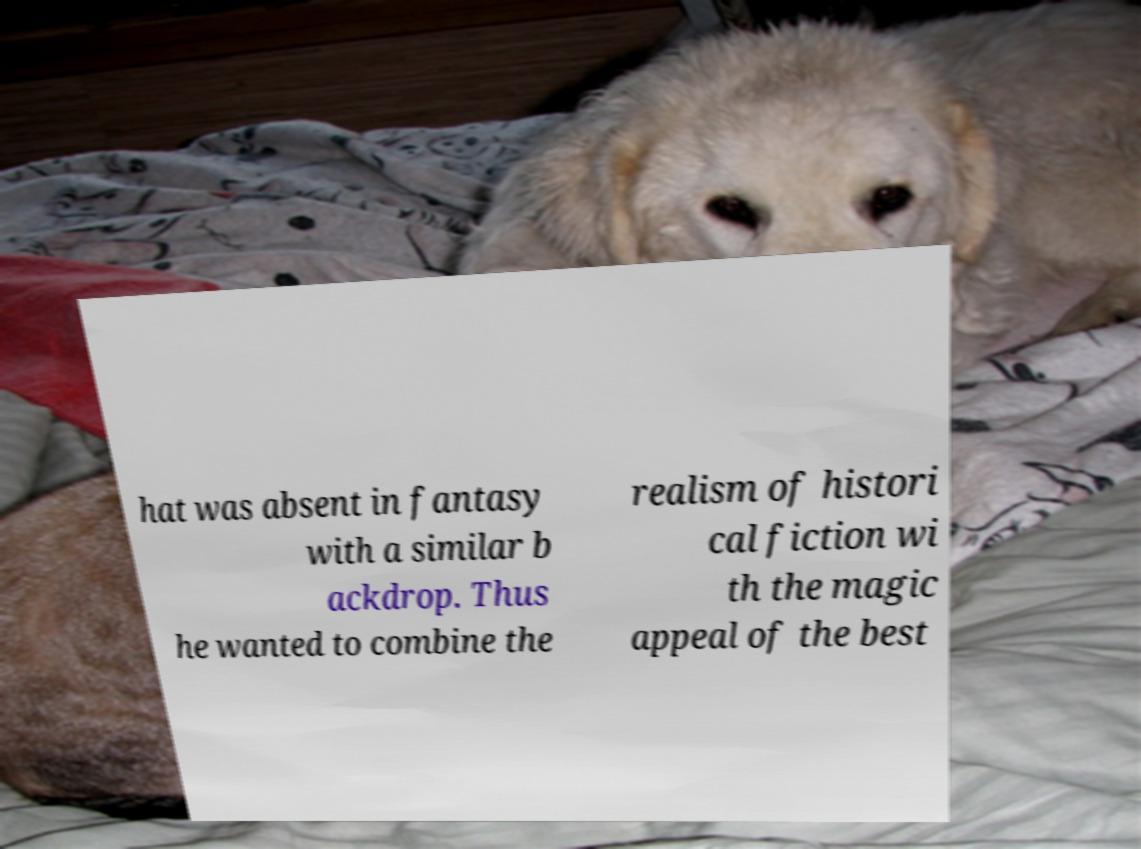Please identify and transcribe the text found in this image. hat was absent in fantasy with a similar b ackdrop. Thus he wanted to combine the realism of histori cal fiction wi th the magic appeal of the best 